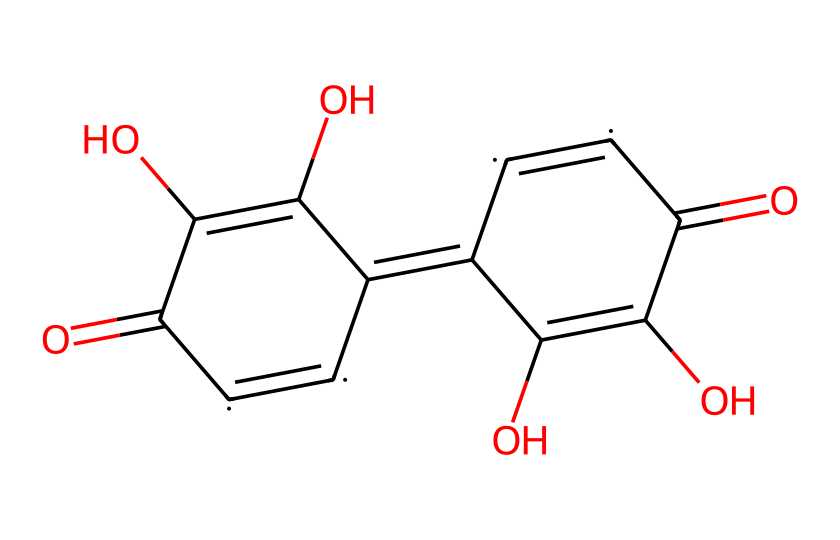What is the main functional group present in graphene oxide? The chemical structure shows multiple oxygen atoms bonded to carbon, indicating the presence of hydroxyl (-OH) and carbonyl (C=O) functional groups. This is characteristic of graphene oxide.
Answer: hydroxyl and carbonyl How many carbon atoms are there in graphene oxide? By examining the chemical structure, we can count the carbon atoms (C) represented in the SMILES notation. There are a total of 12 carbon atoms present.
Answer: 12 What kind of nanomaterial is represented by this structure? The characteristics of graphene oxide, including its layered structure and functional groups, indicate that it falls under the category of two-dimensional nanomaterials.
Answer: two-dimensional What is the oxidation state of the carbon atoms in graphene oxide? In graphene oxide, carbon atoms are bonded to oxygen atoms, which introduces double bonds (C=O) and hydroxyl groups. This implies that the carbon atoms have a higher oxidation state compared to that in pure graphene. The average oxidation state is +2.
Answer: +2 How many double bonds are present in the chemical structure of graphene oxide? By assessing the connections in the structure, we can see that there are six double bonds (C=C and C=O), which are indicated by the equals signs in the SMILES representation.
Answer: 6 What kind of properties do the functional groups in graphene oxide provide for sports equipment? The presence of hydroxyl and carbonyl groups enhances water affinity, mechanical strength, and functional interactions, making it suitable for lightweight, durable sports equipment.
Answer: enhanced properties 